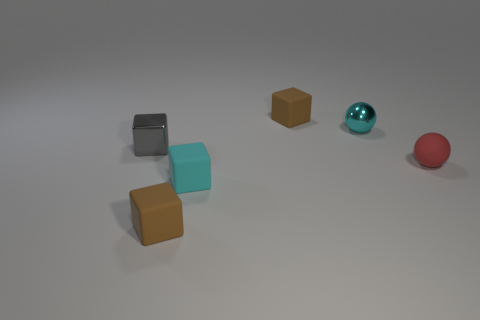Subtract 1 blocks. How many blocks are left? 3 Subtract all purple cubes. Subtract all yellow spheres. How many cubes are left? 4 Add 4 cyan objects. How many objects exist? 10 Subtract all blocks. How many objects are left? 2 Add 2 tiny red balls. How many tiny red balls exist? 3 Subtract 0 blue cubes. How many objects are left? 6 Subtract all large gray blocks. Subtract all small cyan cubes. How many objects are left? 5 Add 3 tiny gray cubes. How many tiny gray cubes are left? 4 